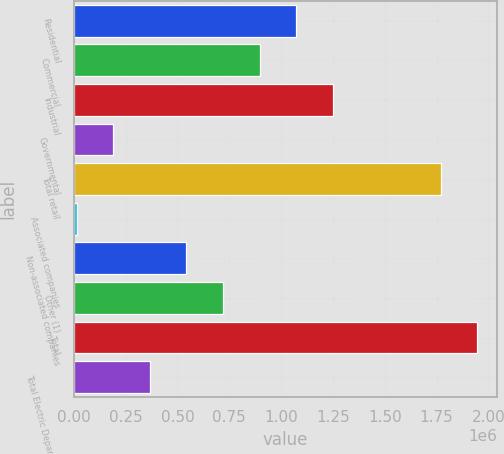Convert chart to OTSL. <chart><loc_0><loc_0><loc_500><loc_500><bar_chart><fcel>Residential<fcel>Commercial<fcel>Industrial<fcel>Governmental<fcel>Total retail<fcel>Associated companies<fcel>Non-associated companies<fcel>Other (1)<fcel>Total<fcel>Total Electric Department<nl><fcel>1.07222e+06<fcel>895878<fcel>1.24856e+06<fcel>190513<fcel>1.76903e+06<fcel>14172<fcel>543196<fcel>719537<fcel>1.94537e+06<fcel>366854<nl></chart> 